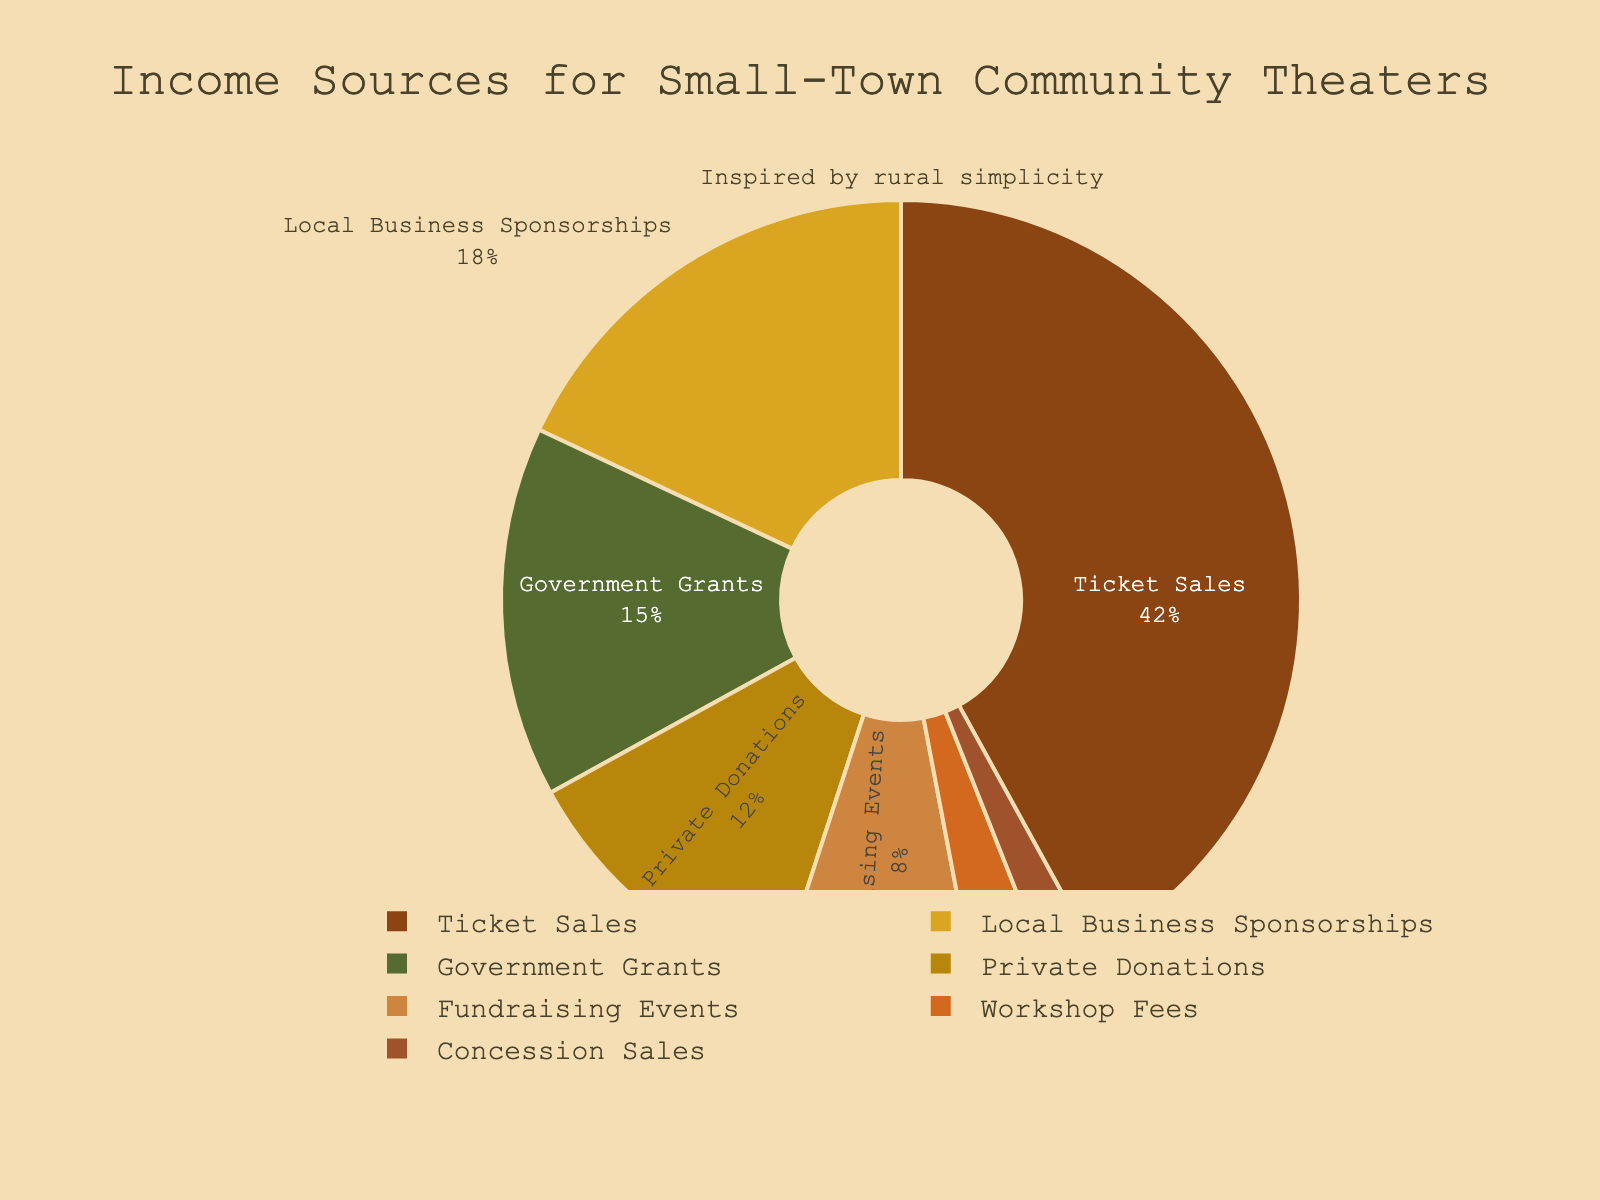What's the percentage contribution of ticket sales? Looking at the pie chart, locate the section labeled "Ticket Sales". The percentage is displayed within this section.
Answer: 42% Which income source contributes the least to community theaters? Identify the smallest segment in the pie chart, which corresponds to the least percentage value. The label inside this segment shows the source.
Answer: Concession Sales What is the total percentage contribution of Government Grants and Private Donations combined? Find the segments labeled "Government Grants" and "Private Donations". Their percentages are 15% and 12%, respectively. Sum these percentages: 15 + 12 = 27%.
Answer: 27% Which income source has a higher percentage: Local Business Sponsorships or Fundraising Events? Compare the segments labeled "Local Business Sponsorships" and "Fundraising Events". Local Business Sponsorships is 18% and Fundraising Events is 8%. 18% is greater than 8%.
Answer: Local Business Sponsorships What's the difference in percentage between Ticket Sales and Workshop Fees? Identify the segments for "Ticket Sales" and "Workshop Fees". Ticket Sales is 42% and Workshop Fees is 3%. Subtract to find the difference: 42 - 3 = 39%.
Answer: 39% How much more does Private Donations contribute compared to Concession Sales? Identify the segments for "Private Donations" and "Concession Sales". Private Donations is 12% and Concession Sales is 2%. Subtract to find the difference: 12 - 2 = 10%.
Answer: 10% What is the combined percentage of the three smallest income sources? Identify the three smallest segments: "Concession Sales" (2%), "Workshop Fees" (3%), and "Fundraising Events" (8%). Sum these percentages: 2 + 3 + 8 = 13%.
Answer: 13% What fraction of the total income is contributed by Local Business Sponsorships? The percentage for Local Business Sponsorships is 18%. To convert this percentage to a fraction, divide by 100: 18/100 = 9/50.
Answer: 9/50 Compare the percentage contribution of Government Grants and Private Donations, which one is higher and by how much? Identify the segments for "Government Grants" (15%) and "Private Donations" (12%). Subtract the smaller from the larger: 15 - 12 = 3%. Government Grants is higher.
Answer: Government Grants by 3% 